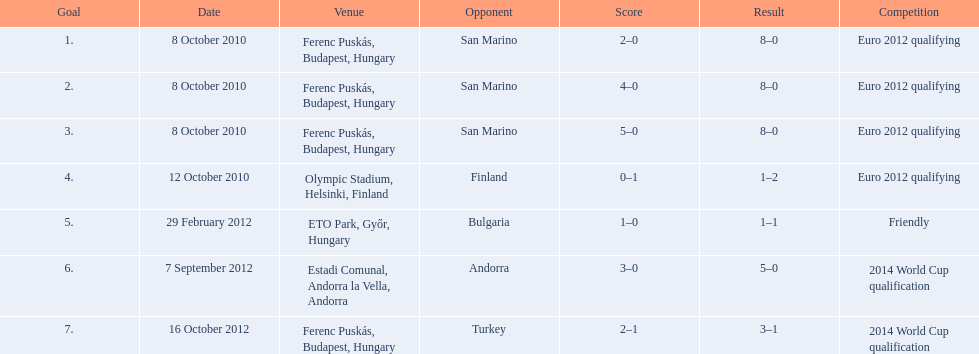Szalai scored just one additional international goal against all other nations combined compared to his score against which single country? San Marino. 